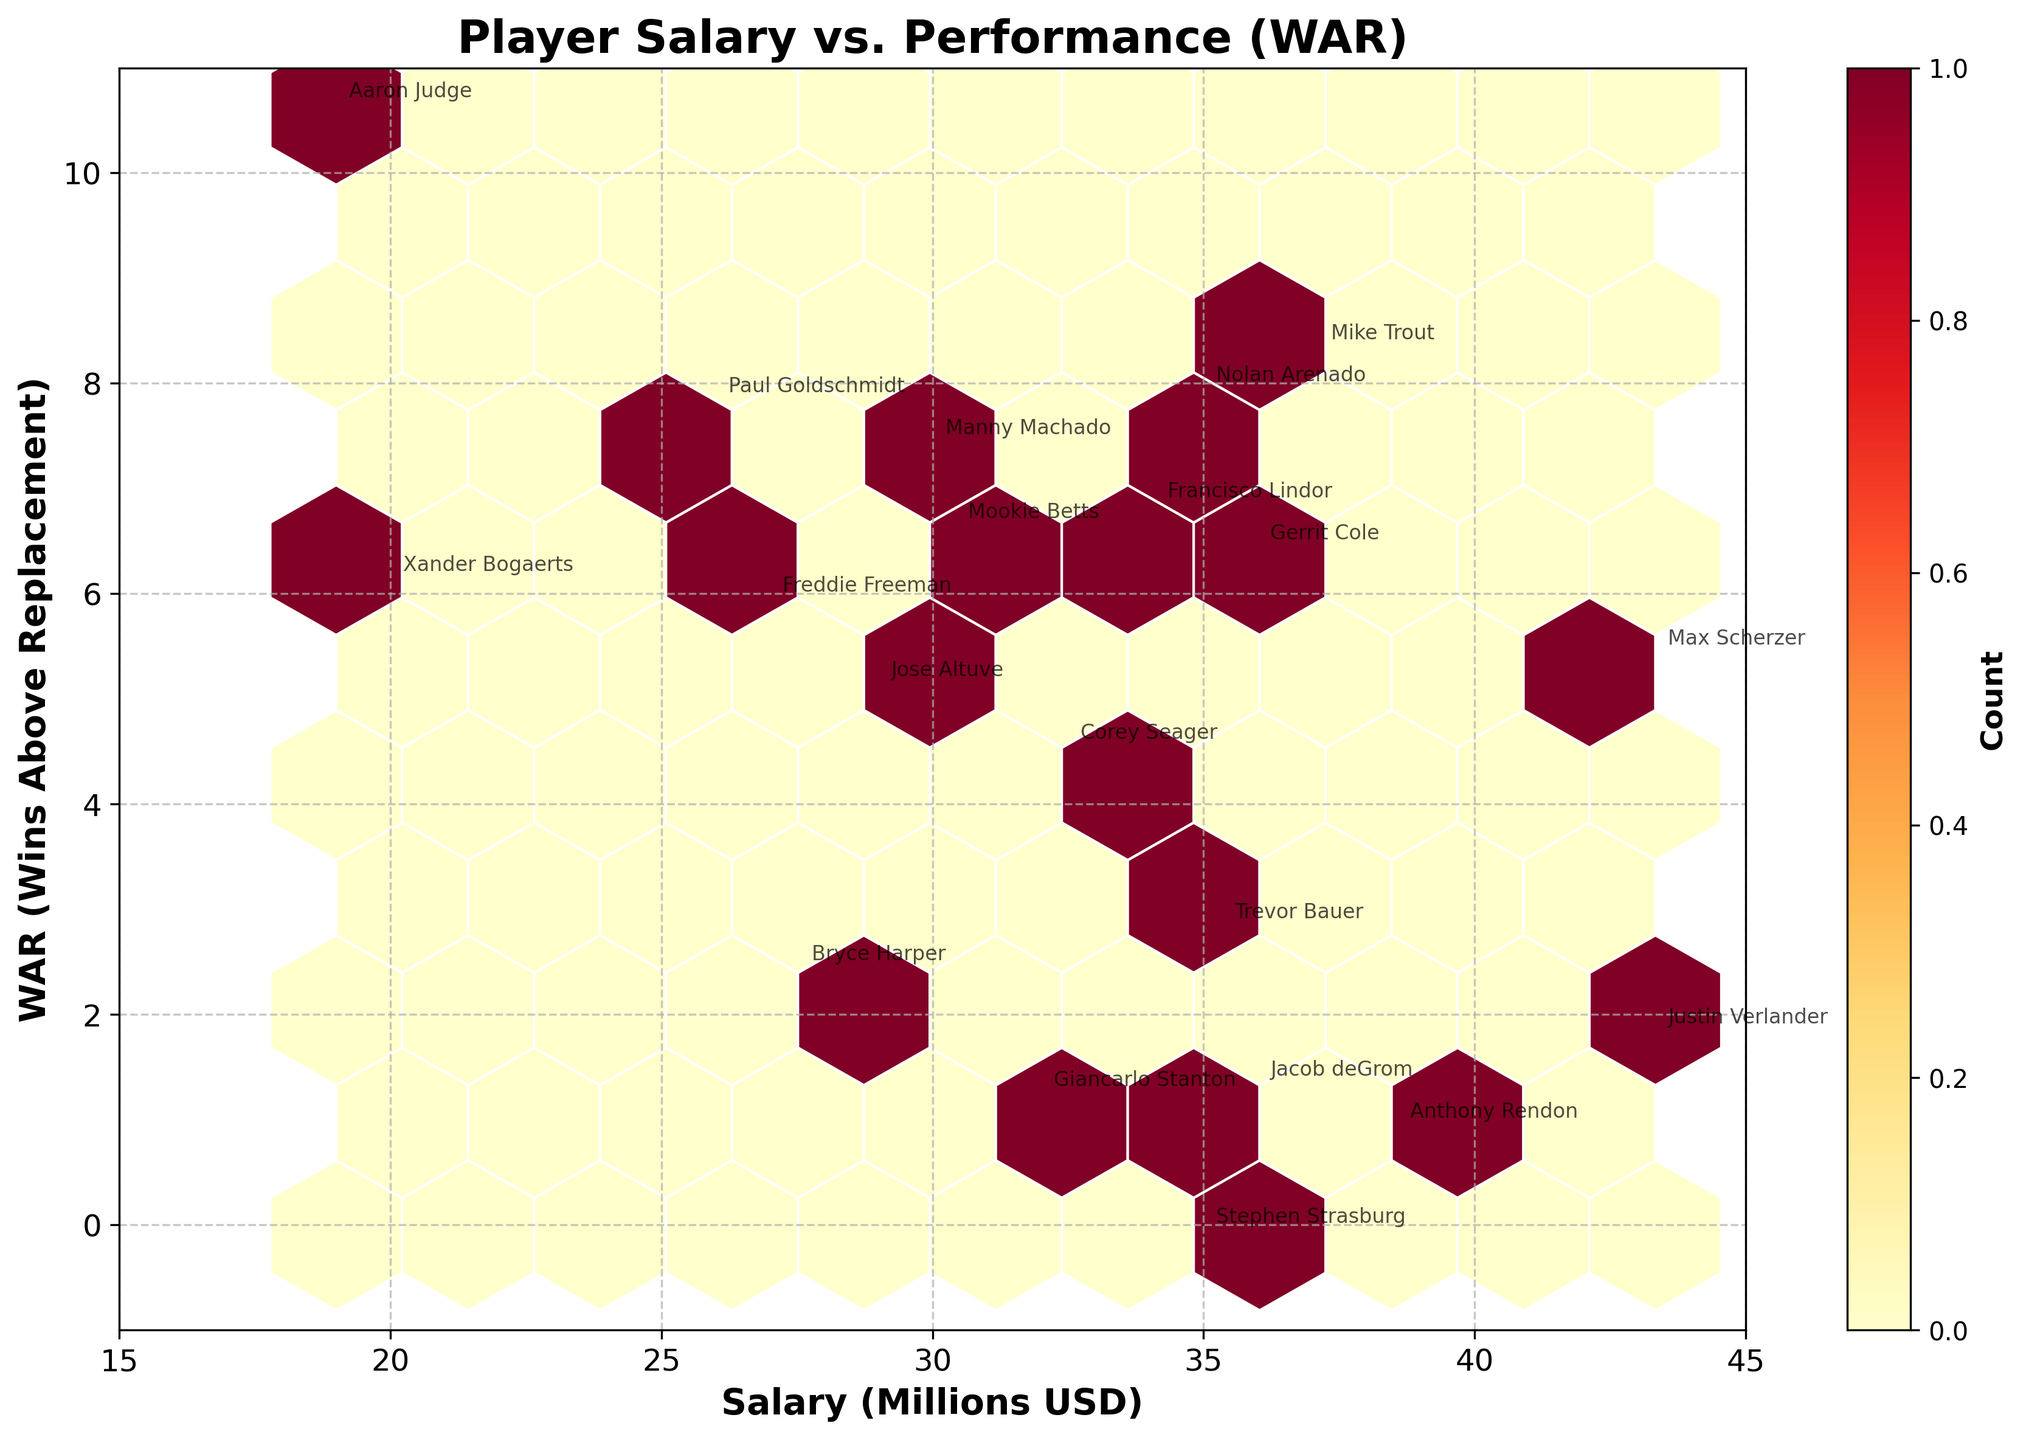What is the title of the plot? The title of the plot is typically placed at the top center of the figure. Here, it clearly states "Player Salary vs. Performance (WAR)".
Answer: Player Salary vs. Performance (WAR) What are the x-axis and y-axis labels? The x-axis label and y-axis label are found on their respective axes. The x-axis is labeled "Salary (Millions USD)", and the y-axis is labeled "WAR (Wins Above Replacement)".
Answer: Salary (Millions USD) and WAR (Wins Above Replacement) How many bins have the highest count and what is that count? The color gradient in the hexbin plot shows the density of data points. The color bar indicates the number of points per bin; the highest count will match the darkest color. The count for the highest density bin, as per the color bar, is visible.
Answer: 7 Which player is plotted at the highest Salary with a negative WAR? Look for the player whose annotation is at the highest position on the x-axis (Salary) and below zero on the y-axis (WAR). The player is Stephen Strasburg.
Answer: Stephen Strasburg Who has the highest WAR and what is their Salary? The player with the highest WAR is at the topmost point on the y-axis. The annotation at this location indicates Aaron Judge, associated with 10.6 WAR and $19 million.
Answer: Aaron Judge, $19 million Which player has the highest Salary and what is their WAR? Identify the player at the farthest point on the x-axis (rightmost). The annotation here will tell us this is Max Scherzer, with a Salary of $43.33 million and a WAR of 5.4.
Answer: Max Scherzer, 5.4 Compare the WAR of Bryce Harper and Giancarlo Stanton. Who has a higher WAR? Locate both players' annotations. Bryce Harper's data point is higher on the y-axis compared to Giancarlo Stanton's, indicating Bryce Harper has a higher WAR.
Answer: Bryce Harper What is the relationship between Salary and WAR as shown on the plot? The overall trend of the hexbin plot can be observed by examining the spread of data points. There is no clear linear trend, showing mixed correlation between Salary and WAR.
Answer: Mixed correlation Calculate the average WAR for players earning more than $30 million. Which players fall into this category and what is the average? Identify players with salaries above $30 million: Mike Trout, Mookie Betts, Gerrit Cole, Max Scherzer, Nolan Arenado, Anthony Rendon, Stephen Strasburg, Justin Verlander, Corey Seager, Francisco Lindor, Trevor Bauer, Jacob deGrom, Manny Machado. Their WARs are 8.3, 6.6, 6.4, 5.4, 7.9, 0.9, -0.1, 1.8, 4.5, 6.8, 2.8, 1.3, and 7.4, respectively. The average is calculated as (8.3 + 6.6 + 6.4 + 5.4 + 7.9 + 0.9 - 0.1 + 1.8 + 4.5 + 6.8 + 2.8 + 1.3 + 7.4) / 13 = 4.8.
Answer: 4.8 Which player’s Salary and WAR combination seems to be an outlier with high WAR compared to salary? Looking for the player with an exceptionally high position on the y-axis (WAR) and relatively low position on the x-axis (Salary), we find Aaron Judge with a WAR of 10.6 at a Salary of $19 million.
Answer: Aaron Judge 